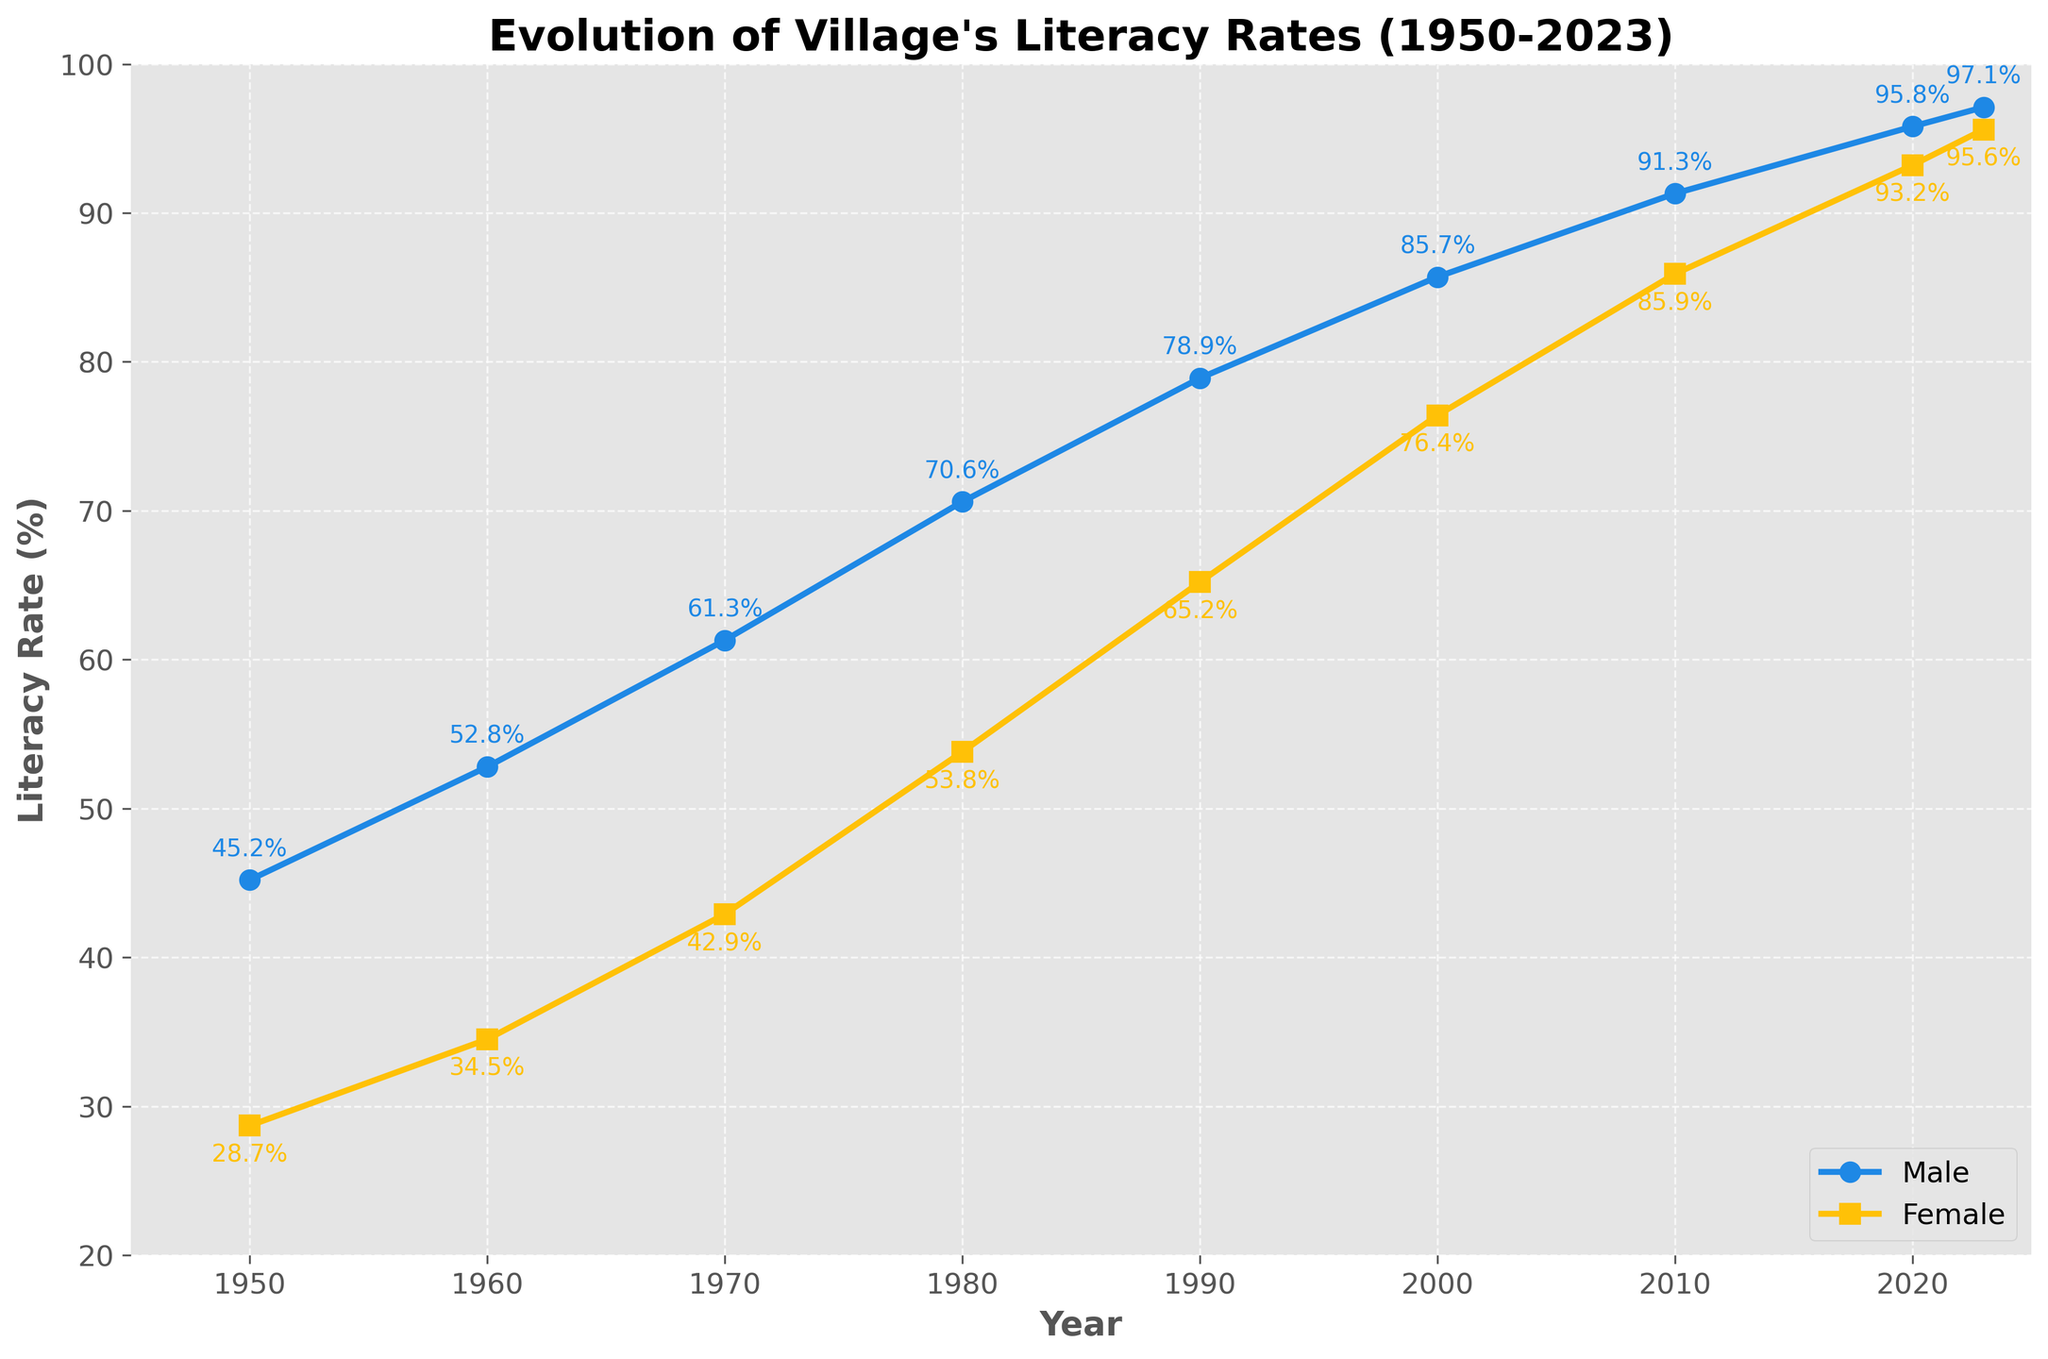Which year shows the highest male literacy rate? By observing the male literacy rates over the years, the highest point for the male literacy rate can be seen at 2023, where the rate is labeled as 97.1%.
Answer: 2023 In which decade was the increase in female literacy rate the greatest? To determine this, we need to calculate the change in female literacy rates for each decade: 
1950-1960: 34.5 - 28.7 = 5.8,
1960-1970: 42.9 - 34.5 = 8.4,
1970-1980: 53.8 - 42.9 = 10.9,
1980-1990: 65.2 - 53.8 = 11.4,
1990-2000: 76.4 - 65.2 = 11.2,
2000-2010: 85.9 - 76.4 = 9.5,
2010-2020: 93.2 - 85.9 = 7.3.
The highest increase occurs in the 1980s (1980-1990) with an 11.4% increase.
Answer: 1980s What is the difference in literacy rates between males and females in the year 2000? For the year 2000, the male literacy rate is 85.7%, and the female literacy rate is 76.4%. The difference can be calculated as 85.7 - 76.4 = 9.3%.
Answer: 9.3% During which year did the female literacy rate surpass 85%? Observing the labels, the female literacy rate first surpasses 85% in the year 2010, where it is noted as 85.9%.
Answer: 2010 What has been the trend in both male and female literacy rates from 1950 to 2023? Both male and female literacy rates show an increasing trend from 1950 to 2023. The lines for both genders consistently rise throughout the years, indicating a steady improvement in literacy rates.
Answer: Increasing By how much did the male literacy rate increase from 1950 to 2023? The male literacy rate in 1950 was 45.2%, and in 2023, it is 97.1%. The increase can be calculated as 97.1 - 45.2 = 51.9%.
Answer: 51.9% In which year was the gap between male and female literacy rates the smallest? To determine this, observe the difference in rates for each year:
1950: 16.5,
1960: 18.3,
1970: 18.4,
1980: 16.8,
1990: 13.7,
2000: 9.3,
2010: 5.4,
2020: 2.6,
2023: 1.5.
The smallest gap appears to be in 2023 with a 1.5% difference.
Answer: 2023 What was the average female literacy rate from 1950 to 2023? To find the average, sum all the female literacy rates and divide by the number of data points: (28.7 + 34.5 + 42.9 + 53.8 + 65.2 + 76.4 + 85.9 + 93.2 + 95.6) / 9 = 575.6 / 9 = 63.96%.
Answer: 63.96% 